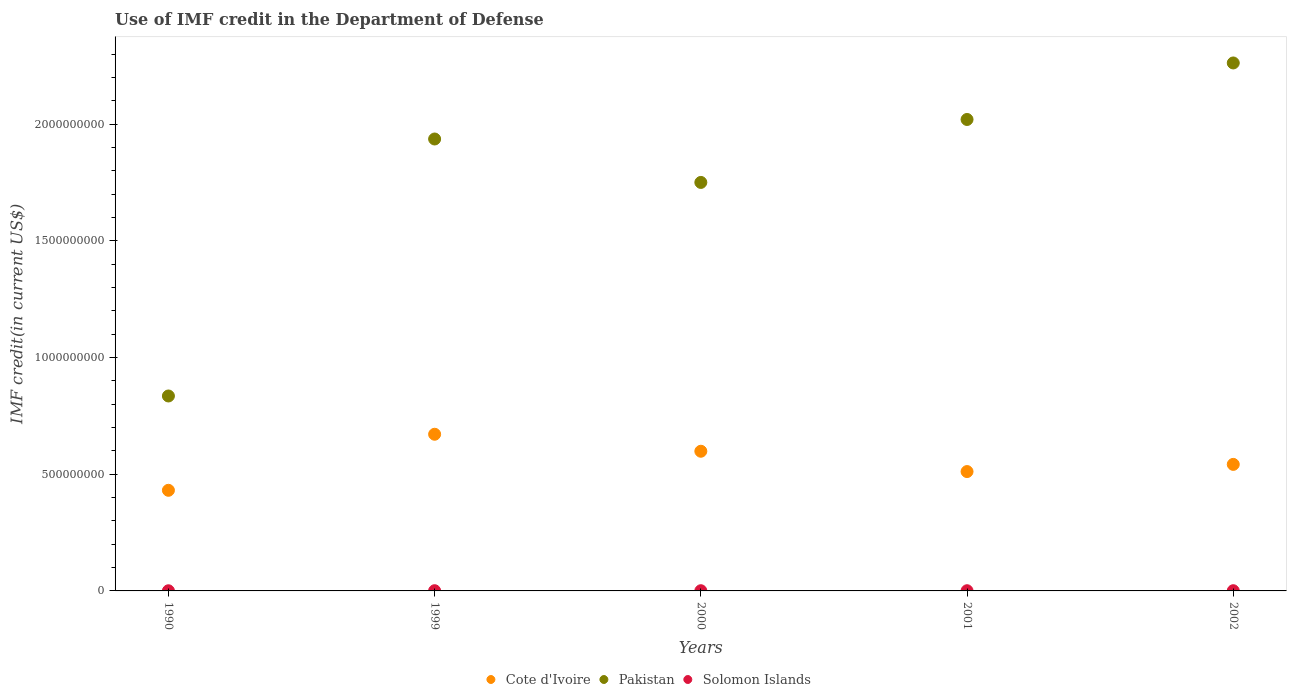What is the IMF credit in the Department of Defense in Cote d'Ivoire in 2002?
Offer a very short reply. 5.42e+08. Across all years, what is the maximum IMF credit in the Department of Defense in Solomon Islands?
Your answer should be compact. 8.98e+05. Across all years, what is the minimum IMF credit in the Department of Defense in Cote d'Ivoire?
Keep it short and to the point. 4.31e+08. In which year was the IMF credit in the Department of Defense in Pakistan maximum?
Ensure brevity in your answer.  2002. In which year was the IMF credit in the Department of Defense in Cote d'Ivoire minimum?
Offer a terse response. 1990. What is the total IMF credit in the Department of Defense in Cote d'Ivoire in the graph?
Give a very brief answer. 2.76e+09. What is the difference between the IMF credit in the Department of Defense in Solomon Islands in 1990 and that in 2002?
Your answer should be compact. -2.23e+05. What is the difference between the IMF credit in the Department of Defense in Solomon Islands in 2000 and the IMF credit in the Department of Defense in Cote d'Ivoire in 2001?
Offer a very short reply. -5.11e+08. What is the average IMF credit in the Department of Defense in Solomon Islands per year?
Make the answer very short. 8.26e+05. In the year 2000, what is the difference between the IMF credit in the Department of Defense in Cote d'Ivoire and IMF credit in the Department of Defense in Solomon Islands?
Make the answer very short. 5.98e+08. What is the ratio of the IMF credit in the Department of Defense in Solomon Islands in 1999 to that in 2002?
Make the answer very short. 1.01. Is the IMF credit in the Department of Defense in Solomon Islands in 1999 less than that in 2001?
Your answer should be compact. No. Is the difference between the IMF credit in the Department of Defense in Cote d'Ivoire in 1999 and 2002 greater than the difference between the IMF credit in the Department of Defense in Solomon Islands in 1999 and 2002?
Make the answer very short. Yes. What is the difference between the highest and the second highest IMF credit in the Department of Defense in Solomon Islands?
Keep it short and to the point. 8000. What is the difference between the highest and the lowest IMF credit in the Department of Defense in Cote d'Ivoire?
Provide a succinct answer. 2.40e+08. Is it the case that in every year, the sum of the IMF credit in the Department of Defense in Pakistan and IMF credit in the Department of Defense in Solomon Islands  is greater than the IMF credit in the Department of Defense in Cote d'Ivoire?
Offer a very short reply. Yes. Does the IMF credit in the Department of Defense in Pakistan monotonically increase over the years?
Provide a short and direct response. No. Is the IMF credit in the Department of Defense in Solomon Islands strictly greater than the IMF credit in the Department of Defense in Pakistan over the years?
Your answer should be very brief. No. Is the IMF credit in the Department of Defense in Solomon Islands strictly less than the IMF credit in the Department of Defense in Pakistan over the years?
Offer a terse response. Yes. How many dotlines are there?
Make the answer very short. 3. How many years are there in the graph?
Offer a terse response. 5. What is the difference between two consecutive major ticks on the Y-axis?
Provide a short and direct response. 5.00e+08. Does the graph contain any zero values?
Offer a terse response. No. Where does the legend appear in the graph?
Offer a very short reply. Bottom center. How are the legend labels stacked?
Offer a terse response. Horizontal. What is the title of the graph?
Your response must be concise. Use of IMF credit in the Department of Defense. Does "Ireland" appear as one of the legend labels in the graph?
Your response must be concise. No. What is the label or title of the X-axis?
Keep it short and to the point. Years. What is the label or title of the Y-axis?
Offer a very short reply. IMF credit(in current US$). What is the IMF credit(in current US$) in Cote d'Ivoire in 1990?
Offer a very short reply. 4.31e+08. What is the IMF credit(in current US$) of Pakistan in 1990?
Make the answer very short. 8.35e+08. What is the IMF credit(in current US$) in Solomon Islands in 1990?
Your answer should be compact. 6.67e+05. What is the IMF credit(in current US$) in Cote d'Ivoire in 1999?
Offer a terse response. 6.71e+08. What is the IMF credit(in current US$) in Pakistan in 1999?
Offer a very short reply. 1.94e+09. What is the IMF credit(in current US$) in Solomon Islands in 1999?
Your answer should be compact. 8.98e+05. What is the IMF credit(in current US$) in Cote d'Ivoire in 2000?
Offer a terse response. 5.99e+08. What is the IMF credit(in current US$) of Pakistan in 2000?
Your answer should be very brief. 1.75e+09. What is the IMF credit(in current US$) of Solomon Islands in 2000?
Your answer should be compact. 8.53e+05. What is the IMF credit(in current US$) of Cote d'Ivoire in 2001?
Ensure brevity in your answer.  5.12e+08. What is the IMF credit(in current US$) in Pakistan in 2001?
Provide a succinct answer. 2.02e+09. What is the IMF credit(in current US$) of Solomon Islands in 2001?
Your answer should be compact. 8.22e+05. What is the IMF credit(in current US$) in Cote d'Ivoire in 2002?
Offer a terse response. 5.42e+08. What is the IMF credit(in current US$) of Pakistan in 2002?
Provide a succinct answer. 2.26e+09. What is the IMF credit(in current US$) of Solomon Islands in 2002?
Provide a succinct answer. 8.90e+05. Across all years, what is the maximum IMF credit(in current US$) of Cote d'Ivoire?
Ensure brevity in your answer.  6.71e+08. Across all years, what is the maximum IMF credit(in current US$) in Pakistan?
Provide a succinct answer. 2.26e+09. Across all years, what is the maximum IMF credit(in current US$) in Solomon Islands?
Give a very brief answer. 8.98e+05. Across all years, what is the minimum IMF credit(in current US$) in Cote d'Ivoire?
Ensure brevity in your answer.  4.31e+08. Across all years, what is the minimum IMF credit(in current US$) in Pakistan?
Offer a very short reply. 8.35e+08. Across all years, what is the minimum IMF credit(in current US$) in Solomon Islands?
Make the answer very short. 6.67e+05. What is the total IMF credit(in current US$) of Cote d'Ivoire in the graph?
Give a very brief answer. 2.76e+09. What is the total IMF credit(in current US$) of Pakistan in the graph?
Provide a succinct answer. 8.81e+09. What is the total IMF credit(in current US$) in Solomon Islands in the graph?
Provide a short and direct response. 4.13e+06. What is the difference between the IMF credit(in current US$) in Cote d'Ivoire in 1990 and that in 1999?
Your response must be concise. -2.40e+08. What is the difference between the IMF credit(in current US$) of Pakistan in 1990 and that in 1999?
Give a very brief answer. -1.10e+09. What is the difference between the IMF credit(in current US$) of Solomon Islands in 1990 and that in 1999?
Offer a very short reply. -2.31e+05. What is the difference between the IMF credit(in current US$) of Cote d'Ivoire in 1990 and that in 2000?
Offer a terse response. -1.67e+08. What is the difference between the IMF credit(in current US$) of Pakistan in 1990 and that in 2000?
Make the answer very short. -9.15e+08. What is the difference between the IMF credit(in current US$) in Solomon Islands in 1990 and that in 2000?
Give a very brief answer. -1.86e+05. What is the difference between the IMF credit(in current US$) in Cote d'Ivoire in 1990 and that in 2001?
Offer a terse response. -8.03e+07. What is the difference between the IMF credit(in current US$) in Pakistan in 1990 and that in 2001?
Ensure brevity in your answer.  -1.19e+09. What is the difference between the IMF credit(in current US$) of Solomon Islands in 1990 and that in 2001?
Provide a short and direct response. -1.55e+05. What is the difference between the IMF credit(in current US$) in Cote d'Ivoire in 1990 and that in 2002?
Keep it short and to the point. -1.11e+08. What is the difference between the IMF credit(in current US$) of Pakistan in 1990 and that in 2002?
Make the answer very short. -1.43e+09. What is the difference between the IMF credit(in current US$) in Solomon Islands in 1990 and that in 2002?
Your answer should be compact. -2.23e+05. What is the difference between the IMF credit(in current US$) in Cote d'Ivoire in 1999 and that in 2000?
Offer a very short reply. 7.28e+07. What is the difference between the IMF credit(in current US$) in Pakistan in 1999 and that in 2000?
Ensure brevity in your answer.  1.86e+08. What is the difference between the IMF credit(in current US$) of Solomon Islands in 1999 and that in 2000?
Keep it short and to the point. 4.50e+04. What is the difference between the IMF credit(in current US$) in Cote d'Ivoire in 1999 and that in 2001?
Your answer should be compact. 1.60e+08. What is the difference between the IMF credit(in current US$) in Pakistan in 1999 and that in 2001?
Provide a succinct answer. -8.37e+07. What is the difference between the IMF credit(in current US$) in Solomon Islands in 1999 and that in 2001?
Make the answer very short. 7.60e+04. What is the difference between the IMF credit(in current US$) of Cote d'Ivoire in 1999 and that in 2002?
Offer a terse response. 1.29e+08. What is the difference between the IMF credit(in current US$) in Pakistan in 1999 and that in 2002?
Your response must be concise. -3.26e+08. What is the difference between the IMF credit(in current US$) in Solomon Islands in 1999 and that in 2002?
Offer a terse response. 8000. What is the difference between the IMF credit(in current US$) of Cote d'Ivoire in 2000 and that in 2001?
Provide a succinct answer. 8.71e+07. What is the difference between the IMF credit(in current US$) in Pakistan in 2000 and that in 2001?
Give a very brief answer. -2.70e+08. What is the difference between the IMF credit(in current US$) of Solomon Islands in 2000 and that in 2001?
Make the answer very short. 3.10e+04. What is the difference between the IMF credit(in current US$) in Cote d'Ivoire in 2000 and that in 2002?
Offer a very short reply. 5.63e+07. What is the difference between the IMF credit(in current US$) of Pakistan in 2000 and that in 2002?
Provide a succinct answer. -5.12e+08. What is the difference between the IMF credit(in current US$) in Solomon Islands in 2000 and that in 2002?
Your response must be concise. -3.70e+04. What is the difference between the IMF credit(in current US$) in Cote d'Ivoire in 2001 and that in 2002?
Offer a very short reply. -3.08e+07. What is the difference between the IMF credit(in current US$) in Pakistan in 2001 and that in 2002?
Ensure brevity in your answer.  -2.42e+08. What is the difference between the IMF credit(in current US$) in Solomon Islands in 2001 and that in 2002?
Your response must be concise. -6.80e+04. What is the difference between the IMF credit(in current US$) in Cote d'Ivoire in 1990 and the IMF credit(in current US$) in Pakistan in 1999?
Provide a succinct answer. -1.51e+09. What is the difference between the IMF credit(in current US$) of Cote d'Ivoire in 1990 and the IMF credit(in current US$) of Solomon Islands in 1999?
Offer a very short reply. 4.30e+08. What is the difference between the IMF credit(in current US$) in Pakistan in 1990 and the IMF credit(in current US$) in Solomon Islands in 1999?
Provide a succinct answer. 8.35e+08. What is the difference between the IMF credit(in current US$) in Cote d'Ivoire in 1990 and the IMF credit(in current US$) in Pakistan in 2000?
Ensure brevity in your answer.  -1.32e+09. What is the difference between the IMF credit(in current US$) of Cote d'Ivoire in 1990 and the IMF credit(in current US$) of Solomon Islands in 2000?
Offer a terse response. 4.30e+08. What is the difference between the IMF credit(in current US$) in Pakistan in 1990 and the IMF credit(in current US$) in Solomon Islands in 2000?
Your answer should be compact. 8.35e+08. What is the difference between the IMF credit(in current US$) of Cote d'Ivoire in 1990 and the IMF credit(in current US$) of Pakistan in 2001?
Offer a terse response. -1.59e+09. What is the difference between the IMF credit(in current US$) of Cote d'Ivoire in 1990 and the IMF credit(in current US$) of Solomon Islands in 2001?
Your answer should be very brief. 4.30e+08. What is the difference between the IMF credit(in current US$) of Pakistan in 1990 and the IMF credit(in current US$) of Solomon Islands in 2001?
Offer a very short reply. 8.35e+08. What is the difference between the IMF credit(in current US$) in Cote d'Ivoire in 1990 and the IMF credit(in current US$) in Pakistan in 2002?
Offer a terse response. -1.83e+09. What is the difference between the IMF credit(in current US$) of Cote d'Ivoire in 1990 and the IMF credit(in current US$) of Solomon Islands in 2002?
Ensure brevity in your answer.  4.30e+08. What is the difference between the IMF credit(in current US$) in Pakistan in 1990 and the IMF credit(in current US$) in Solomon Islands in 2002?
Offer a very short reply. 8.35e+08. What is the difference between the IMF credit(in current US$) of Cote d'Ivoire in 1999 and the IMF credit(in current US$) of Pakistan in 2000?
Your answer should be very brief. -1.08e+09. What is the difference between the IMF credit(in current US$) in Cote d'Ivoire in 1999 and the IMF credit(in current US$) in Solomon Islands in 2000?
Your response must be concise. 6.71e+08. What is the difference between the IMF credit(in current US$) in Pakistan in 1999 and the IMF credit(in current US$) in Solomon Islands in 2000?
Ensure brevity in your answer.  1.94e+09. What is the difference between the IMF credit(in current US$) of Cote d'Ivoire in 1999 and the IMF credit(in current US$) of Pakistan in 2001?
Your response must be concise. -1.35e+09. What is the difference between the IMF credit(in current US$) in Cote d'Ivoire in 1999 and the IMF credit(in current US$) in Solomon Islands in 2001?
Your answer should be compact. 6.71e+08. What is the difference between the IMF credit(in current US$) in Pakistan in 1999 and the IMF credit(in current US$) in Solomon Islands in 2001?
Provide a succinct answer. 1.94e+09. What is the difference between the IMF credit(in current US$) in Cote d'Ivoire in 1999 and the IMF credit(in current US$) in Pakistan in 2002?
Give a very brief answer. -1.59e+09. What is the difference between the IMF credit(in current US$) of Cote d'Ivoire in 1999 and the IMF credit(in current US$) of Solomon Islands in 2002?
Ensure brevity in your answer.  6.71e+08. What is the difference between the IMF credit(in current US$) in Pakistan in 1999 and the IMF credit(in current US$) in Solomon Islands in 2002?
Your response must be concise. 1.94e+09. What is the difference between the IMF credit(in current US$) in Cote d'Ivoire in 2000 and the IMF credit(in current US$) in Pakistan in 2001?
Your response must be concise. -1.42e+09. What is the difference between the IMF credit(in current US$) of Cote d'Ivoire in 2000 and the IMF credit(in current US$) of Solomon Islands in 2001?
Offer a very short reply. 5.98e+08. What is the difference between the IMF credit(in current US$) in Pakistan in 2000 and the IMF credit(in current US$) in Solomon Islands in 2001?
Provide a succinct answer. 1.75e+09. What is the difference between the IMF credit(in current US$) of Cote d'Ivoire in 2000 and the IMF credit(in current US$) of Pakistan in 2002?
Your response must be concise. -1.66e+09. What is the difference between the IMF credit(in current US$) of Cote d'Ivoire in 2000 and the IMF credit(in current US$) of Solomon Islands in 2002?
Offer a terse response. 5.98e+08. What is the difference between the IMF credit(in current US$) of Pakistan in 2000 and the IMF credit(in current US$) of Solomon Islands in 2002?
Your answer should be very brief. 1.75e+09. What is the difference between the IMF credit(in current US$) of Cote d'Ivoire in 2001 and the IMF credit(in current US$) of Pakistan in 2002?
Your response must be concise. -1.75e+09. What is the difference between the IMF credit(in current US$) of Cote d'Ivoire in 2001 and the IMF credit(in current US$) of Solomon Islands in 2002?
Provide a succinct answer. 5.11e+08. What is the difference between the IMF credit(in current US$) of Pakistan in 2001 and the IMF credit(in current US$) of Solomon Islands in 2002?
Your response must be concise. 2.02e+09. What is the average IMF credit(in current US$) in Cote d'Ivoire per year?
Provide a succinct answer. 5.51e+08. What is the average IMF credit(in current US$) in Pakistan per year?
Offer a very short reply. 1.76e+09. What is the average IMF credit(in current US$) in Solomon Islands per year?
Your answer should be compact. 8.26e+05. In the year 1990, what is the difference between the IMF credit(in current US$) in Cote d'Ivoire and IMF credit(in current US$) in Pakistan?
Make the answer very short. -4.04e+08. In the year 1990, what is the difference between the IMF credit(in current US$) of Cote d'Ivoire and IMF credit(in current US$) of Solomon Islands?
Give a very brief answer. 4.31e+08. In the year 1990, what is the difference between the IMF credit(in current US$) of Pakistan and IMF credit(in current US$) of Solomon Islands?
Your answer should be very brief. 8.35e+08. In the year 1999, what is the difference between the IMF credit(in current US$) in Cote d'Ivoire and IMF credit(in current US$) in Pakistan?
Provide a short and direct response. -1.27e+09. In the year 1999, what is the difference between the IMF credit(in current US$) of Cote d'Ivoire and IMF credit(in current US$) of Solomon Islands?
Provide a short and direct response. 6.71e+08. In the year 1999, what is the difference between the IMF credit(in current US$) of Pakistan and IMF credit(in current US$) of Solomon Islands?
Your response must be concise. 1.94e+09. In the year 2000, what is the difference between the IMF credit(in current US$) of Cote d'Ivoire and IMF credit(in current US$) of Pakistan?
Provide a succinct answer. -1.15e+09. In the year 2000, what is the difference between the IMF credit(in current US$) of Cote d'Ivoire and IMF credit(in current US$) of Solomon Islands?
Offer a very short reply. 5.98e+08. In the year 2000, what is the difference between the IMF credit(in current US$) of Pakistan and IMF credit(in current US$) of Solomon Islands?
Provide a short and direct response. 1.75e+09. In the year 2001, what is the difference between the IMF credit(in current US$) in Cote d'Ivoire and IMF credit(in current US$) in Pakistan?
Provide a short and direct response. -1.51e+09. In the year 2001, what is the difference between the IMF credit(in current US$) of Cote d'Ivoire and IMF credit(in current US$) of Solomon Islands?
Your response must be concise. 5.11e+08. In the year 2001, what is the difference between the IMF credit(in current US$) in Pakistan and IMF credit(in current US$) in Solomon Islands?
Your answer should be compact. 2.02e+09. In the year 2002, what is the difference between the IMF credit(in current US$) of Cote d'Ivoire and IMF credit(in current US$) of Pakistan?
Make the answer very short. -1.72e+09. In the year 2002, what is the difference between the IMF credit(in current US$) in Cote d'Ivoire and IMF credit(in current US$) in Solomon Islands?
Your answer should be compact. 5.41e+08. In the year 2002, what is the difference between the IMF credit(in current US$) in Pakistan and IMF credit(in current US$) in Solomon Islands?
Make the answer very short. 2.26e+09. What is the ratio of the IMF credit(in current US$) in Cote d'Ivoire in 1990 to that in 1999?
Offer a very short reply. 0.64. What is the ratio of the IMF credit(in current US$) of Pakistan in 1990 to that in 1999?
Your answer should be very brief. 0.43. What is the ratio of the IMF credit(in current US$) of Solomon Islands in 1990 to that in 1999?
Give a very brief answer. 0.74. What is the ratio of the IMF credit(in current US$) in Cote d'Ivoire in 1990 to that in 2000?
Your answer should be very brief. 0.72. What is the ratio of the IMF credit(in current US$) in Pakistan in 1990 to that in 2000?
Ensure brevity in your answer.  0.48. What is the ratio of the IMF credit(in current US$) of Solomon Islands in 1990 to that in 2000?
Your answer should be very brief. 0.78. What is the ratio of the IMF credit(in current US$) of Cote d'Ivoire in 1990 to that in 2001?
Offer a very short reply. 0.84. What is the ratio of the IMF credit(in current US$) in Pakistan in 1990 to that in 2001?
Your response must be concise. 0.41. What is the ratio of the IMF credit(in current US$) in Solomon Islands in 1990 to that in 2001?
Give a very brief answer. 0.81. What is the ratio of the IMF credit(in current US$) in Cote d'Ivoire in 1990 to that in 2002?
Ensure brevity in your answer.  0.8. What is the ratio of the IMF credit(in current US$) in Pakistan in 1990 to that in 2002?
Your answer should be compact. 0.37. What is the ratio of the IMF credit(in current US$) in Solomon Islands in 1990 to that in 2002?
Give a very brief answer. 0.75. What is the ratio of the IMF credit(in current US$) of Cote d'Ivoire in 1999 to that in 2000?
Your answer should be very brief. 1.12. What is the ratio of the IMF credit(in current US$) of Pakistan in 1999 to that in 2000?
Your answer should be very brief. 1.11. What is the ratio of the IMF credit(in current US$) in Solomon Islands in 1999 to that in 2000?
Offer a terse response. 1.05. What is the ratio of the IMF credit(in current US$) in Cote d'Ivoire in 1999 to that in 2001?
Offer a very short reply. 1.31. What is the ratio of the IMF credit(in current US$) in Pakistan in 1999 to that in 2001?
Offer a terse response. 0.96. What is the ratio of the IMF credit(in current US$) of Solomon Islands in 1999 to that in 2001?
Offer a very short reply. 1.09. What is the ratio of the IMF credit(in current US$) of Cote d'Ivoire in 1999 to that in 2002?
Offer a terse response. 1.24. What is the ratio of the IMF credit(in current US$) of Pakistan in 1999 to that in 2002?
Offer a terse response. 0.86. What is the ratio of the IMF credit(in current US$) in Cote d'Ivoire in 2000 to that in 2001?
Your response must be concise. 1.17. What is the ratio of the IMF credit(in current US$) of Pakistan in 2000 to that in 2001?
Ensure brevity in your answer.  0.87. What is the ratio of the IMF credit(in current US$) of Solomon Islands in 2000 to that in 2001?
Provide a succinct answer. 1.04. What is the ratio of the IMF credit(in current US$) in Cote d'Ivoire in 2000 to that in 2002?
Provide a short and direct response. 1.1. What is the ratio of the IMF credit(in current US$) of Pakistan in 2000 to that in 2002?
Provide a short and direct response. 0.77. What is the ratio of the IMF credit(in current US$) of Solomon Islands in 2000 to that in 2002?
Provide a short and direct response. 0.96. What is the ratio of the IMF credit(in current US$) in Cote d'Ivoire in 2001 to that in 2002?
Ensure brevity in your answer.  0.94. What is the ratio of the IMF credit(in current US$) in Pakistan in 2001 to that in 2002?
Your response must be concise. 0.89. What is the ratio of the IMF credit(in current US$) of Solomon Islands in 2001 to that in 2002?
Give a very brief answer. 0.92. What is the difference between the highest and the second highest IMF credit(in current US$) in Cote d'Ivoire?
Offer a very short reply. 7.28e+07. What is the difference between the highest and the second highest IMF credit(in current US$) in Pakistan?
Keep it short and to the point. 2.42e+08. What is the difference between the highest and the second highest IMF credit(in current US$) of Solomon Islands?
Your answer should be very brief. 8000. What is the difference between the highest and the lowest IMF credit(in current US$) of Cote d'Ivoire?
Keep it short and to the point. 2.40e+08. What is the difference between the highest and the lowest IMF credit(in current US$) in Pakistan?
Offer a terse response. 1.43e+09. What is the difference between the highest and the lowest IMF credit(in current US$) in Solomon Islands?
Your answer should be compact. 2.31e+05. 